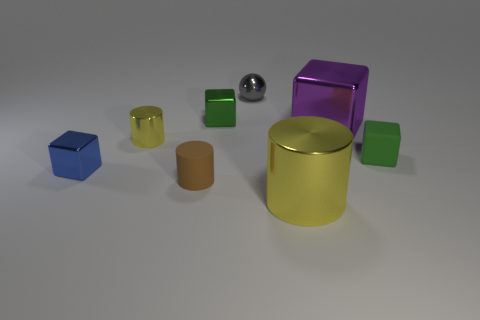How many other things are there of the same color as the tiny ball?
Keep it short and to the point. 0. The green shiny thing that is the same size as the brown rubber object is what shape?
Your answer should be very brief. Cube. What number of big things are either rubber cylinders or cubes?
Ensure brevity in your answer.  1. There is a tiny green matte object that is on the right side of the large shiny thing that is on the left side of the purple shiny cube; is there a small blue shiny block that is behind it?
Your answer should be very brief. No. Is there a metallic cylinder that has the same size as the brown rubber thing?
Your answer should be very brief. Yes. What material is the brown thing that is the same size as the gray object?
Ensure brevity in your answer.  Rubber. There is a blue metallic object; is it the same size as the green thing in front of the green shiny object?
Offer a very short reply. Yes. What number of metal objects are tiny blocks or small yellow objects?
Provide a short and direct response. 3. What number of tiny green shiny objects have the same shape as the tiny blue metal thing?
Make the answer very short. 1. What is the material of the other tiny cube that is the same color as the rubber cube?
Give a very brief answer. Metal. 